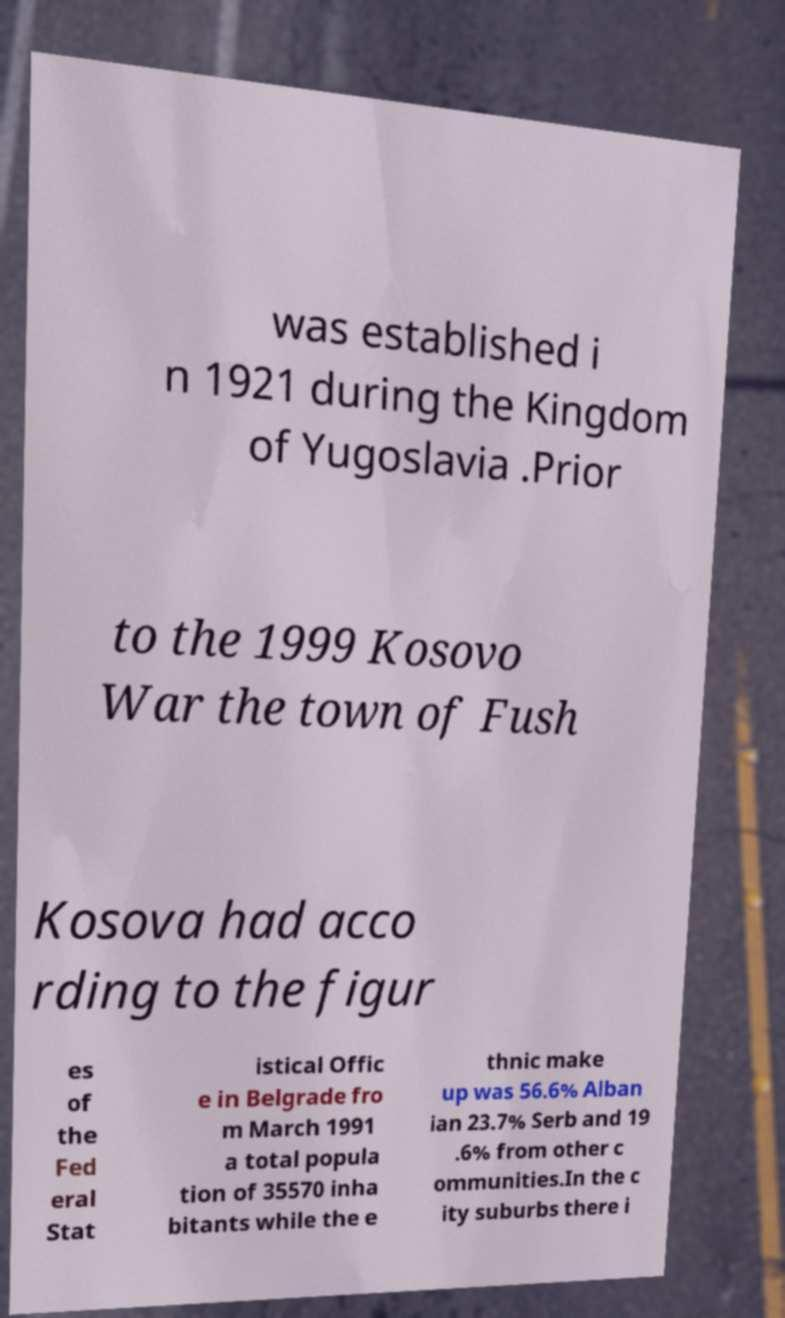Please read and relay the text visible in this image. What does it say? was established i n 1921 during the Kingdom of Yugoslavia .Prior to the 1999 Kosovo War the town of Fush Kosova had acco rding to the figur es of the Fed eral Stat istical Offic e in Belgrade fro m March 1991 a total popula tion of 35570 inha bitants while the e thnic make up was 56.6% Alban ian 23.7% Serb and 19 .6% from other c ommunities.In the c ity suburbs there i 